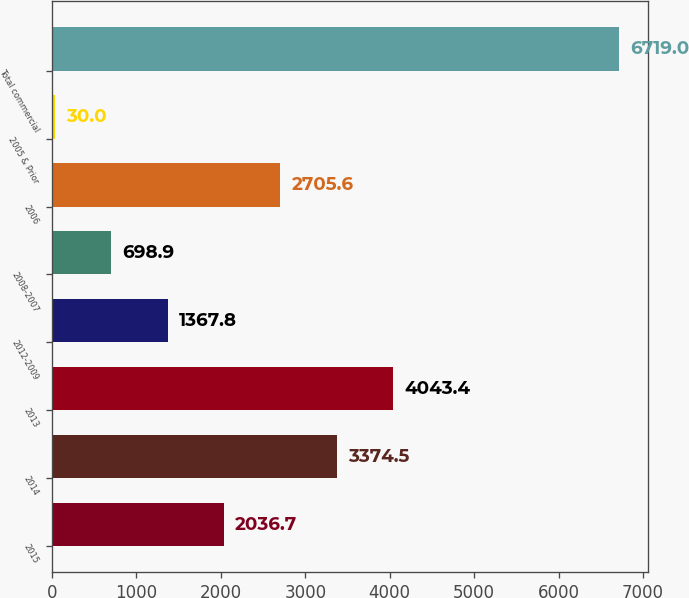Convert chart. <chart><loc_0><loc_0><loc_500><loc_500><bar_chart><fcel>2015<fcel>2014<fcel>2013<fcel>2012-2009<fcel>2008-2007<fcel>2006<fcel>2005 & Prior<fcel>Total commercial<nl><fcel>2036.7<fcel>3374.5<fcel>4043.4<fcel>1367.8<fcel>698.9<fcel>2705.6<fcel>30<fcel>6719<nl></chart> 